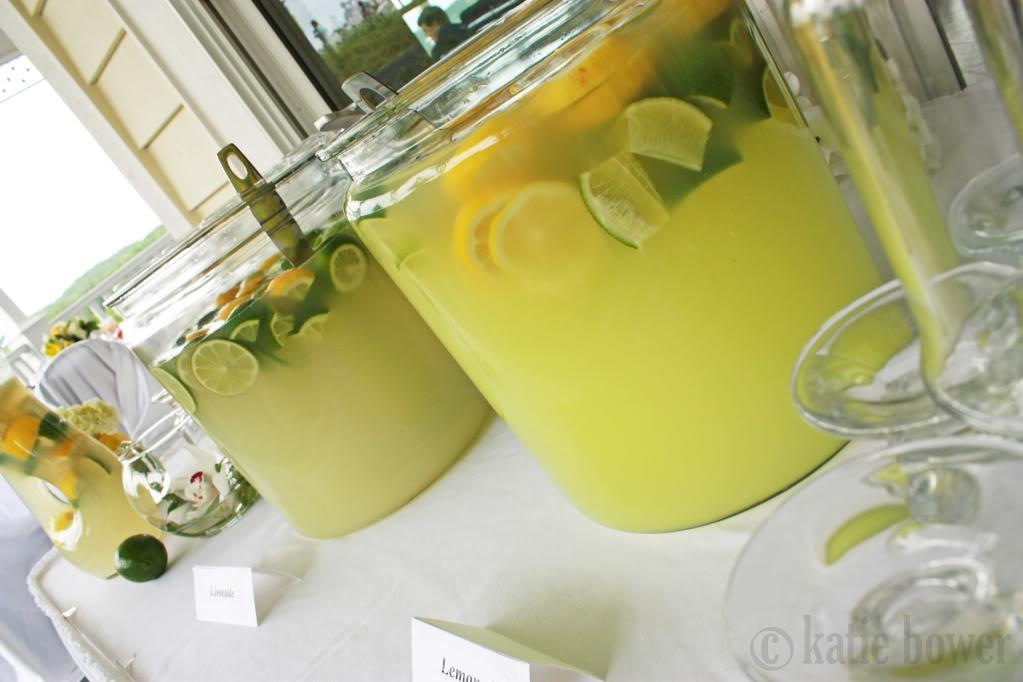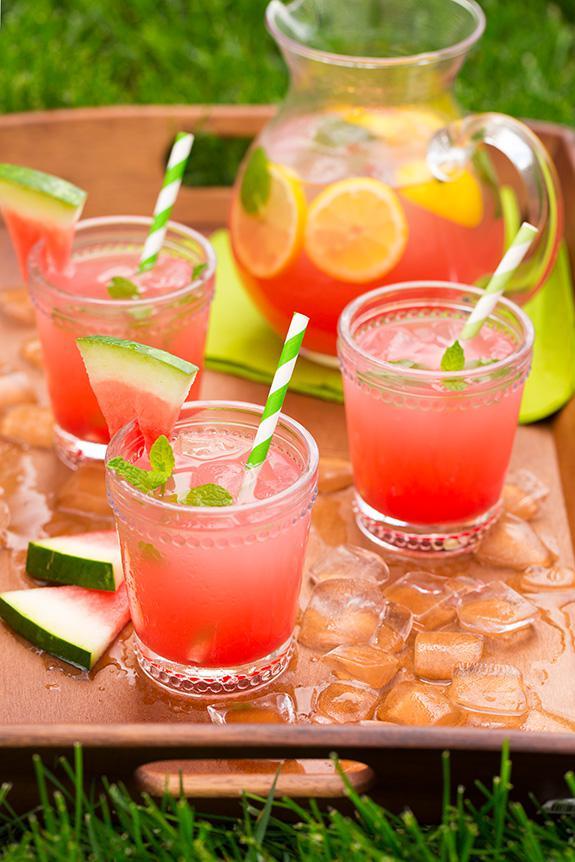The first image is the image on the left, the second image is the image on the right. For the images displayed, is the sentence "An image shows glasses garnished with green leaves and watermelon slices." factually correct? Answer yes or no. Yes. 